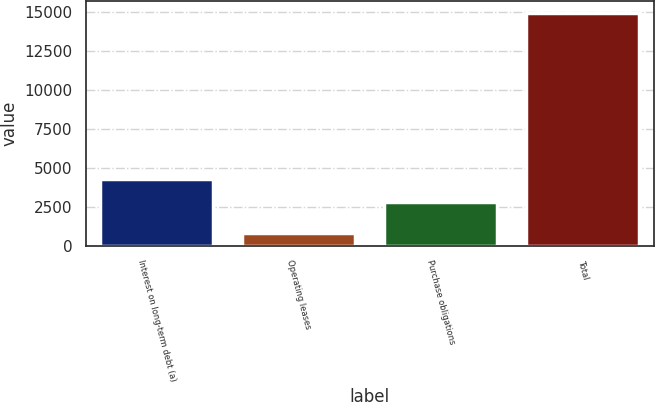<chart> <loc_0><loc_0><loc_500><loc_500><bar_chart><fcel>Interest on long-term debt (a)<fcel>Operating leases<fcel>Purchase obligations<fcel>Total<nl><fcel>4308<fcel>822<fcel>2809<fcel>14972<nl></chart> 